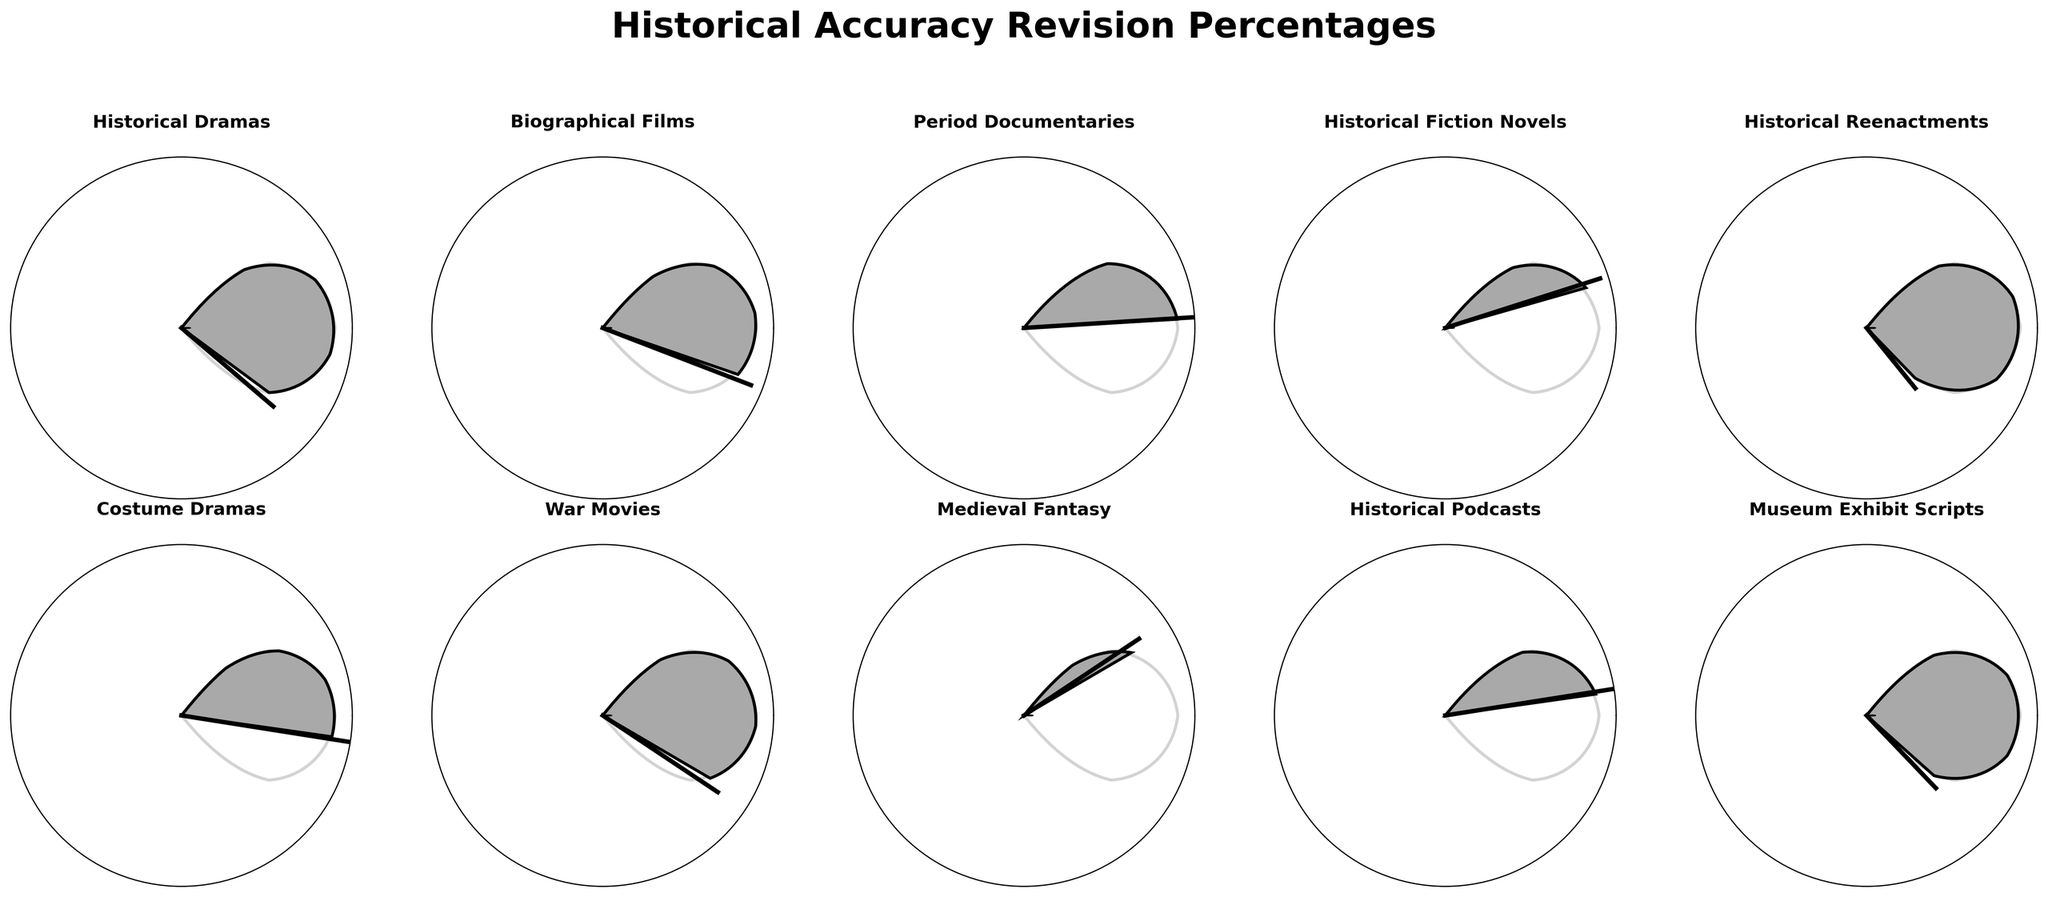What's the highest percentage of script revisions due to historical inaccuracies? The 'Historical Reenactments' gauge chart shows a value of 85%, which is the highest among all content types.
Answer: 85% Which content type has the lowest percentage of script revisions? The 'Medieval Fantasy' gauge chart indicates a value of 30%, the lowest percentage among all content types.
Answer: 30% How many content types have revision percentages above 60%? By observing the gauge charts, the content types with revision percentages above 60% are 'Historical Dramas', 'Biographical Films', 'Historical Reenactments', 'War Movies', and 'Museum Exhibit Scripts'. That makes 5 content types.
Answer: 5 What is the average revision percentage for 'Historical Dramas', 'Biographical Films', and 'Period Documentaries'? Add the percentages for these three content types: 75% (Historical Dramas) + 62% (Biographical Films) + 48% (Period Documentaries) = 185%. Then divide by 3 to find the average: 185 / 3 = approximately 61.67%.
Answer: 61.67% Which content type has a revision percentage closest to 50%? 'Costume Dramas' has a revision percentage of 55%, which is the closest to 50% among all content types.
Answer: 55% What's the difference between the highest and the lowest revision percentages? The highest percentage is 85% (Historical Reenactments) and the lowest is 30% (Medieval Fantasy). The difference is 85 - 30 = 55%.
Answer: 55% Which content type revision percentage is precisely halfway between 40% and 80%? 60% is halfway between 40% and 80%. 'War Movies' has a revision percentage of 70%, which is closest to the midpoint. However, no content type has a precise value of 60%.
Answer: None How does the percentage for 'Historical Podcasts' compare to 'Museum Exhibit Scripts'? 'Historical Podcasts' has a revision percentage of 45%, while 'Museum Exhibit Scripts' has 80%, making 'Museum Exhibit Scripts' higher by 35%.
Answer: 35% Are there more content types with revision percentages above 70% or below 50%? The content types above 70% are 'Historical Dramas', 'Historical Reenactments', 'War Movies', and 'Museum Exhibit Scripts' — 4 in total. Content types below 50% are 'Period Documentaries', 'Historical Fiction Novels', 'Medieval Fantasy', and 'Historical Podcasts' — also 4 in total. Therefore, the counts are equal.
Answer: Equal What’s the median revision percentage among all content types? Order the percentages: 30%, 40%, 45%, 48%, 55%, 62%, 70%, 75%, 80%, 85%. As there are 10 values, the median is the average of the 5th and 6th values: (55 + 62) / 2 = 58.5%.
Answer: 58.5% 